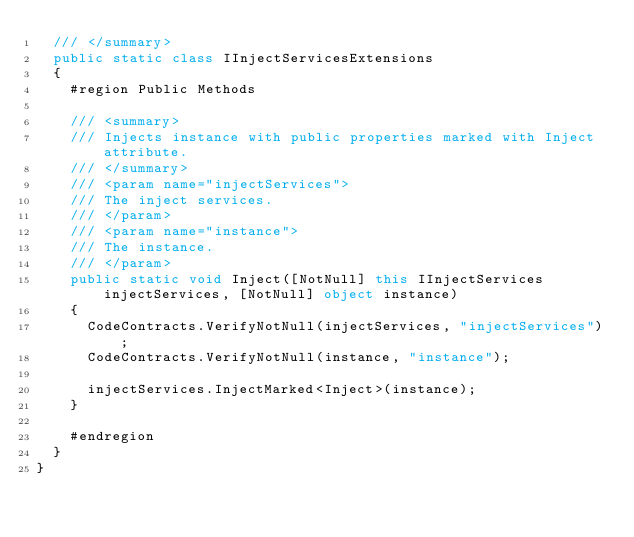Convert code to text. <code><loc_0><loc_0><loc_500><loc_500><_C#_>  /// </summary>
  public static class IInjectServicesExtensions
  {
    #region Public Methods

    /// <summary>
    /// Injects instance with public properties marked with Inject attribute.
    /// </summary>
    /// <param name="injectServices">
    /// The inject services.
    /// </param>
    /// <param name="instance">
    /// The instance.
    /// </param>
    public static void Inject([NotNull] this IInjectServices injectServices, [NotNull] object instance)
    {
      CodeContracts.VerifyNotNull(injectServices, "injectServices");
      CodeContracts.VerifyNotNull(instance, "instance");

      injectServices.InjectMarked<Inject>(instance);
    }

    #endregion
  }
}</code> 